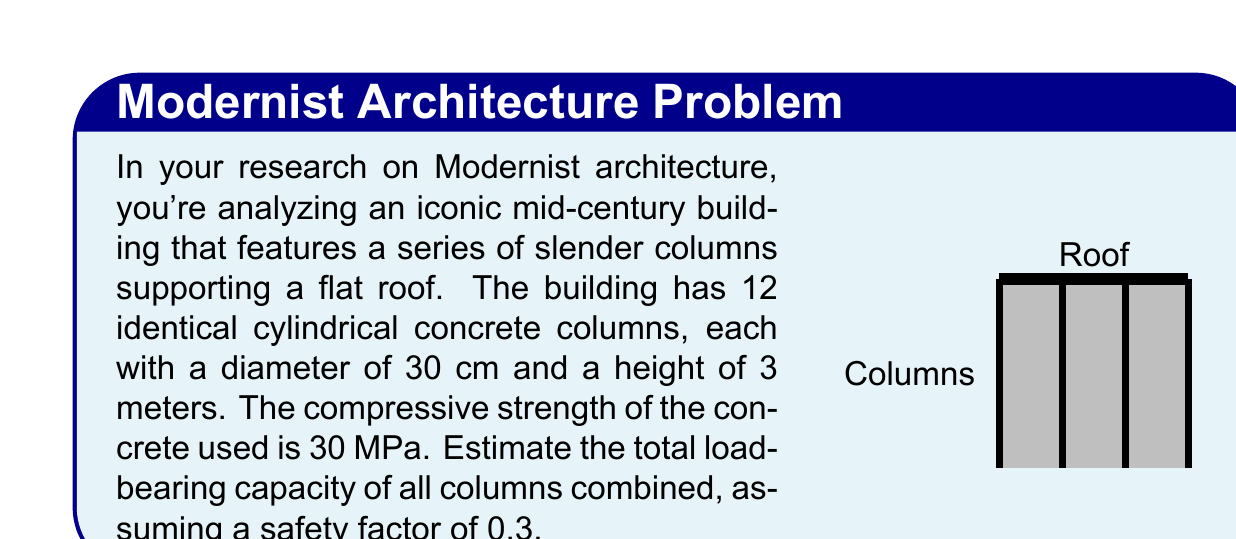Show me your answer to this math problem. Let's approach this step-by-step:

1) First, we need to calculate the cross-sectional area of each column:
   $$A = \pi r^2 = \pi (15\text{ cm})^2 = 706.86\text{ cm}^2 = 0.070686\text{ m}^2$$

2) The load-bearing capacity of a single column can be calculated using the formula:
   $$P = f_c \times A \times SF$$
   Where:
   $P$ is the load-bearing capacity
   $f_c$ is the compressive strength of concrete (30 MPa)
   $A$ is the cross-sectional area of the column
   $SF$ is the safety factor (0.3)

3) Let's substitute these values:
   $$P = 30\text{ MPa} \times 0.070686\text{ m}^2 \times 0.3$$
   $$P = 0.636174\text{ MN} = 636.174\text{ kN}$$

4) Since there are 12 identical columns, we multiply this by 12:
   $$P_{\text{total}} = 636.174\text{ kN} \times 12 = 7634.088\text{ kN}$$

5) Rounding to a reasonable number of significant figures:
   $$P_{\text{total}} \approx 7630\text{ kN}$$
Answer: 7630 kN 